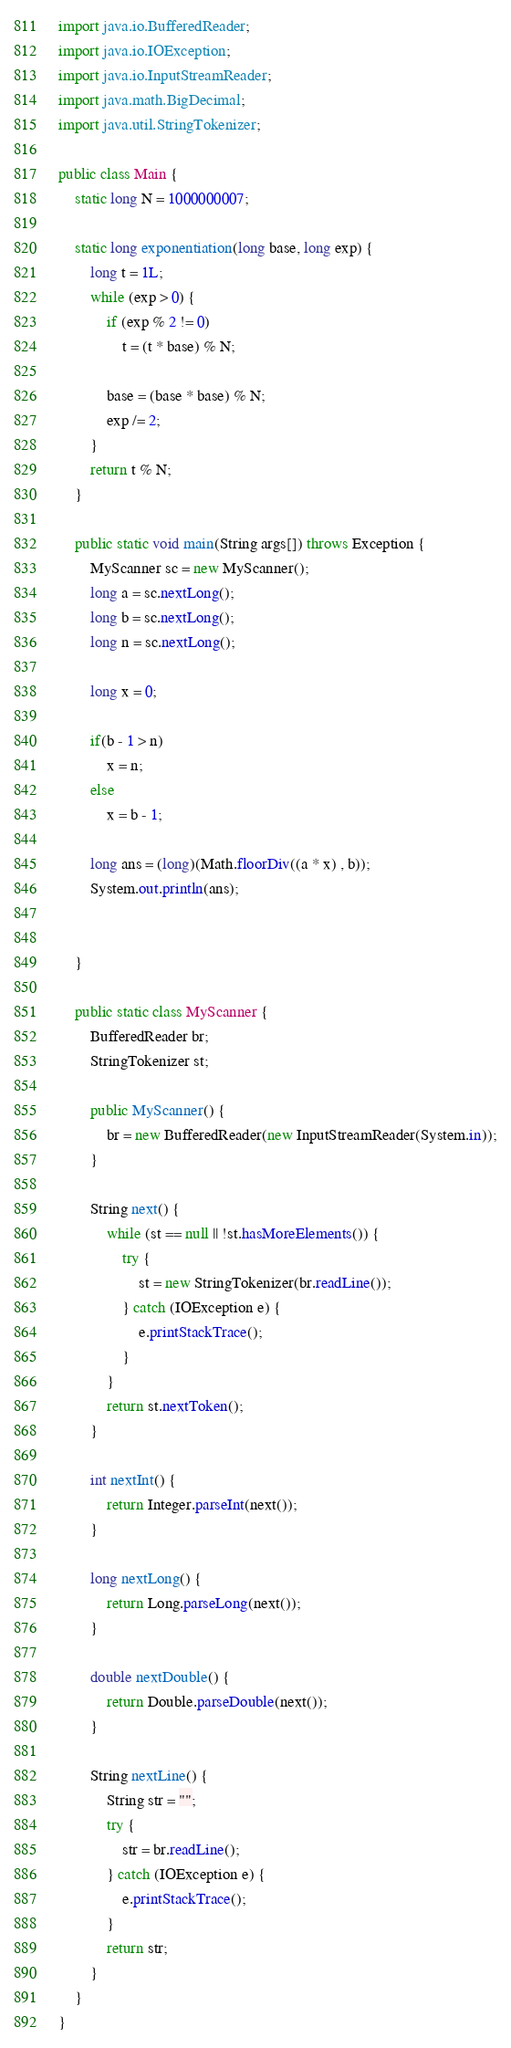<code> <loc_0><loc_0><loc_500><loc_500><_Java_>

import java.io.BufferedReader;
import java.io.IOException;
import java.io.InputStreamReader;
import java.math.BigDecimal;
import java.util.StringTokenizer;

public class Main {
	static long N = 1000000007;

	static long exponentiation(long base, long exp) {
		long t = 1L;
		while (exp > 0) {
			if (exp % 2 != 0)
				t = (t * base) % N;

			base = (base * base) % N;
			exp /= 2;
		}
		return t % N;
	}

	public static void main(String args[]) throws Exception {
		MyScanner sc = new MyScanner();
		long a = sc.nextLong();
		long b = sc.nextLong();
		long n = sc.nextLong();
		
		long x = 0;
		
		if(b - 1 > n)
			x = n;
		else
			x = b - 1;
		
		long ans = (long)(Math.floorDiv((a * x) , b));
		System.out.println(ans);
		
		
	}

	public static class MyScanner {
		BufferedReader br;
		StringTokenizer st;

		public MyScanner() {
			br = new BufferedReader(new InputStreamReader(System.in));
		}

		String next() {
			while (st == null || !st.hasMoreElements()) {
				try {
					st = new StringTokenizer(br.readLine());
				} catch (IOException e) {
					e.printStackTrace();
				}
			}
			return st.nextToken();
		}

		int nextInt() {
			return Integer.parseInt(next());
		}

		long nextLong() {
			return Long.parseLong(next());
		}

		double nextDouble() {
			return Double.parseDouble(next());
		}

		String nextLine() {
			String str = "";
			try {
				str = br.readLine();
			} catch (IOException e) {
				e.printStackTrace();
			}
			return str;
		}
	}
}</code> 